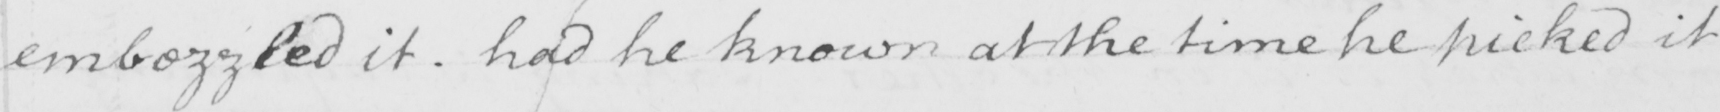What does this handwritten line say? embezzled it . had he known at the time he picked it 